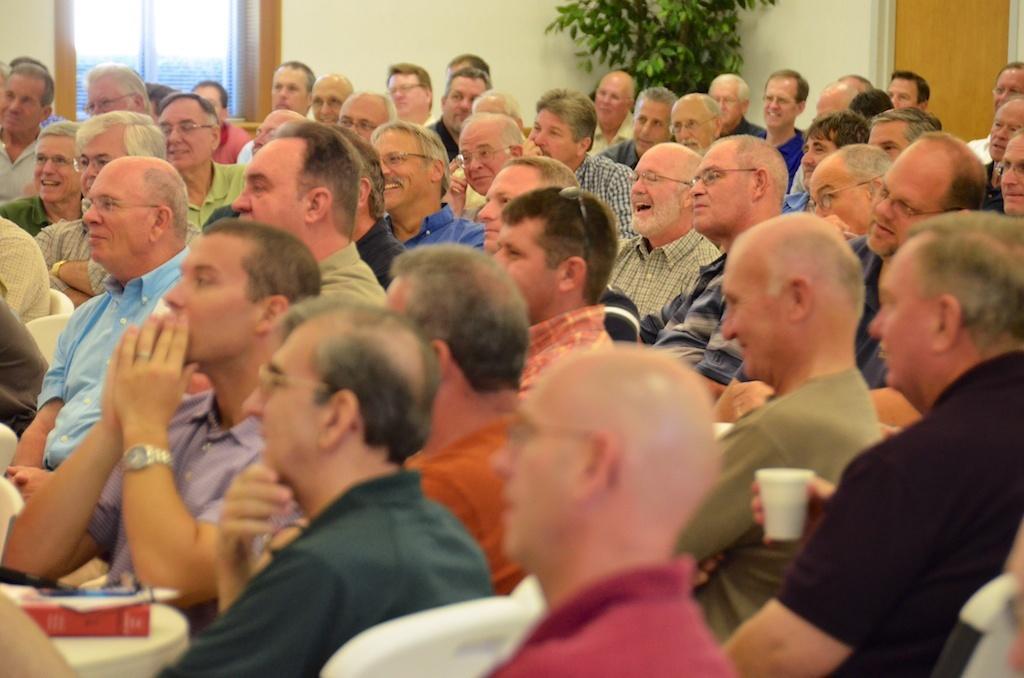Could you give a brief overview of what you see in this image? In this picture I can see many men who are sitting on the chair. In the bottom left corner I can see the book on the table. At the top I can see the plant which is placed near to the wall. In the top right corner I can see the door. In the top left corner I can see the window. 